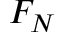<formula> <loc_0><loc_0><loc_500><loc_500>F _ { N }</formula> 